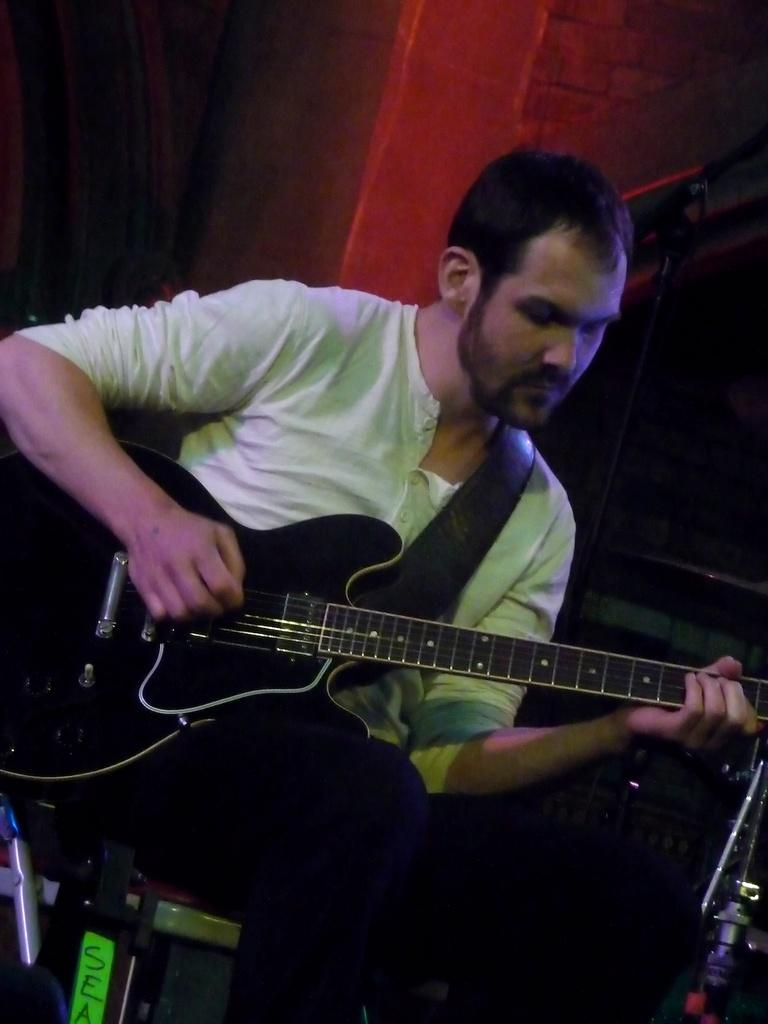Who is present in the image? There is a man in the image. What is the man doing in the image? The man is sitting on a chair and holding a guitar. What can be seen in the background of the image? There is a wall visible in the background of the image. What type of amusement can be seen in the image? There is no amusement present in the image; it features a man sitting on a chair and holding a guitar. How does the man look in the image? The image does not provide information about the man's appearance or expression. 